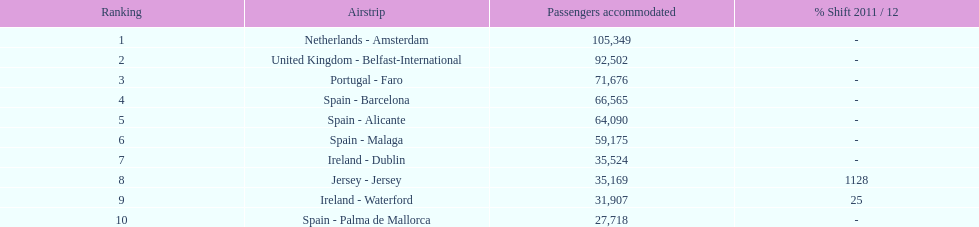What is the name of the sole airport in portugal that ranks among the top 10 busiest routes to and from london southend airport in 2012? Portugal - Faro. 